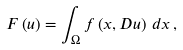Convert formula to latex. <formula><loc_0><loc_0><loc_500><loc_500>F \left ( u \right ) = \int _ { \Omega } f \left ( x , D u \right ) \, d x \, ,</formula> 